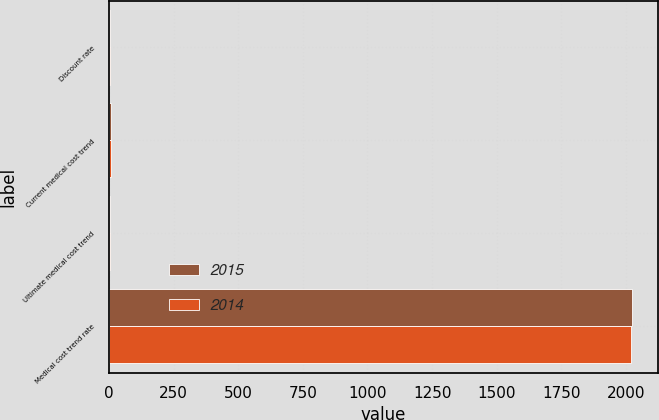<chart> <loc_0><loc_0><loc_500><loc_500><stacked_bar_chart><ecel><fcel>Discount rate<fcel>Current medical cost trend<fcel>Ultimate medical cost trend<fcel>Medical cost trend rate<nl><fcel>2015<fcel>3.9<fcel>5.8<fcel>4.75<fcel>2023<nl><fcel>2014<fcel>4.8<fcel>6.5<fcel>4.75<fcel>2021<nl></chart> 